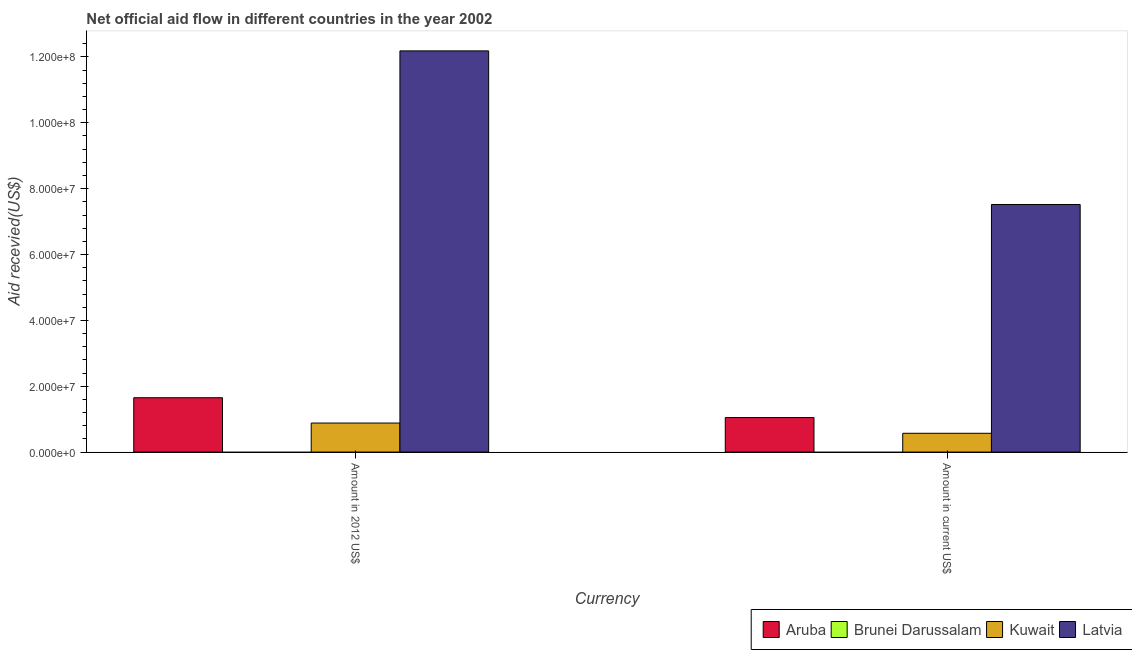How many different coloured bars are there?
Keep it short and to the point. 3. How many groups of bars are there?
Your response must be concise. 2. Are the number of bars per tick equal to the number of legend labels?
Your response must be concise. No. Are the number of bars on each tick of the X-axis equal?
Your answer should be compact. Yes. What is the label of the 2nd group of bars from the left?
Your answer should be very brief. Amount in current US$. What is the amount of aid received(expressed in us$) in Aruba?
Your answer should be compact. 1.05e+07. Across all countries, what is the maximum amount of aid received(expressed in 2012 us$)?
Provide a succinct answer. 1.22e+08. Across all countries, what is the minimum amount of aid received(expressed in us$)?
Your response must be concise. 0. In which country was the amount of aid received(expressed in 2012 us$) maximum?
Provide a succinct answer. Latvia. What is the total amount of aid received(expressed in 2012 us$) in the graph?
Make the answer very short. 1.47e+08. What is the difference between the amount of aid received(expressed in us$) in Latvia and that in Kuwait?
Ensure brevity in your answer.  6.95e+07. What is the difference between the amount of aid received(expressed in 2012 us$) in Kuwait and the amount of aid received(expressed in us$) in Aruba?
Offer a terse response. -1.67e+06. What is the average amount of aid received(expressed in 2012 us$) per country?
Provide a succinct answer. 3.68e+07. What is the difference between the amount of aid received(expressed in 2012 us$) and amount of aid received(expressed in us$) in Latvia?
Make the answer very short. 4.66e+07. What is the ratio of the amount of aid received(expressed in us$) in Latvia to that in Aruba?
Give a very brief answer. 7.17. Is the amount of aid received(expressed in us$) in Aruba less than that in Latvia?
Offer a very short reply. Yes. How many bars are there?
Your response must be concise. 6. Are all the bars in the graph horizontal?
Offer a terse response. No. How many countries are there in the graph?
Keep it short and to the point. 4. Are the values on the major ticks of Y-axis written in scientific E-notation?
Keep it short and to the point. Yes. Does the graph contain grids?
Your answer should be compact. No. Where does the legend appear in the graph?
Provide a succinct answer. Bottom right. How many legend labels are there?
Provide a succinct answer. 4. What is the title of the graph?
Provide a short and direct response. Net official aid flow in different countries in the year 2002. What is the label or title of the X-axis?
Provide a short and direct response. Currency. What is the label or title of the Y-axis?
Your response must be concise. Aid recevied(US$). What is the Aid recevied(US$) in Aruba in Amount in 2012 US$?
Provide a short and direct response. 1.65e+07. What is the Aid recevied(US$) in Kuwait in Amount in 2012 US$?
Your answer should be very brief. 8.82e+06. What is the Aid recevied(US$) of Latvia in Amount in 2012 US$?
Make the answer very short. 1.22e+08. What is the Aid recevied(US$) of Aruba in Amount in current US$?
Ensure brevity in your answer.  1.05e+07. What is the Aid recevied(US$) of Kuwait in Amount in current US$?
Offer a very short reply. 5.71e+06. What is the Aid recevied(US$) in Latvia in Amount in current US$?
Give a very brief answer. 7.52e+07. Across all Currency, what is the maximum Aid recevied(US$) of Aruba?
Ensure brevity in your answer.  1.65e+07. Across all Currency, what is the maximum Aid recevied(US$) of Kuwait?
Offer a very short reply. 8.82e+06. Across all Currency, what is the maximum Aid recevied(US$) in Latvia?
Provide a succinct answer. 1.22e+08. Across all Currency, what is the minimum Aid recevied(US$) in Aruba?
Make the answer very short. 1.05e+07. Across all Currency, what is the minimum Aid recevied(US$) in Kuwait?
Your answer should be very brief. 5.71e+06. Across all Currency, what is the minimum Aid recevied(US$) of Latvia?
Keep it short and to the point. 7.52e+07. What is the total Aid recevied(US$) of Aruba in the graph?
Your response must be concise. 2.70e+07. What is the total Aid recevied(US$) in Brunei Darussalam in the graph?
Give a very brief answer. 0. What is the total Aid recevied(US$) of Kuwait in the graph?
Your answer should be compact. 1.45e+07. What is the total Aid recevied(US$) of Latvia in the graph?
Provide a succinct answer. 1.97e+08. What is the difference between the Aid recevied(US$) in Aruba in Amount in 2012 US$ and that in Amount in current US$?
Offer a very short reply. 6.02e+06. What is the difference between the Aid recevied(US$) of Kuwait in Amount in 2012 US$ and that in Amount in current US$?
Ensure brevity in your answer.  3.11e+06. What is the difference between the Aid recevied(US$) in Latvia in Amount in 2012 US$ and that in Amount in current US$?
Your answer should be very brief. 4.66e+07. What is the difference between the Aid recevied(US$) of Aruba in Amount in 2012 US$ and the Aid recevied(US$) of Kuwait in Amount in current US$?
Your answer should be compact. 1.08e+07. What is the difference between the Aid recevied(US$) of Aruba in Amount in 2012 US$ and the Aid recevied(US$) of Latvia in Amount in current US$?
Your answer should be compact. -5.87e+07. What is the difference between the Aid recevied(US$) in Kuwait in Amount in 2012 US$ and the Aid recevied(US$) in Latvia in Amount in current US$?
Your answer should be compact. -6.64e+07. What is the average Aid recevied(US$) in Aruba per Currency?
Provide a short and direct response. 1.35e+07. What is the average Aid recevied(US$) of Kuwait per Currency?
Provide a succinct answer. 7.26e+06. What is the average Aid recevied(US$) in Latvia per Currency?
Offer a terse response. 9.85e+07. What is the difference between the Aid recevied(US$) of Aruba and Aid recevied(US$) of Kuwait in Amount in 2012 US$?
Ensure brevity in your answer.  7.69e+06. What is the difference between the Aid recevied(US$) of Aruba and Aid recevied(US$) of Latvia in Amount in 2012 US$?
Your answer should be compact. -1.05e+08. What is the difference between the Aid recevied(US$) in Kuwait and Aid recevied(US$) in Latvia in Amount in 2012 US$?
Your answer should be compact. -1.13e+08. What is the difference between the Aid recevied(US$) in Aruba and Aid recevied(US$) in Kuwait in Amount in current US$?
Offer a very short reply. 4.78e+06. What is the difference between the Aid recevied(US$) of Aruba and Aid recevied(US$) of Latvia in Amount in current US$?
Provide a succinct answer. -6.47e+07. What is the difference between the Aid recevied(US$) of Kuwait and Aid recevied(US$) of Latvia in Amount in current US$?
Offer a terse response. -6.95e+07. What is the ratio of the Aid recevied(US$) in Aruba in Amount in 2012 US$ to that in Amount in current US$?
Offer a terse response. 1.57. What is the ratio of the Aid recevied(US$) in Kuwait in Amount in 2012 US$ to that in Amount in current US$?
Your answer should be very brief. 1.54. What is the ratio of the Aid recevied(US$) in Latvia in Amount in 2012 US$ to that in Amount in current US$?
Your response must be concise. 1.62. What is the difference between the highest and the second highest Aid recevied(US$) in Aruba?
Offer a terse response. 6.02e+06. What is the difference between the highest and the second highest Aid recevied(US$) of Kuwait?
Your answer should be very brief. 3.11e+06. What is the difference between the highest and the second highest Aid recevied(US$) in Latvia?
Give a very brief answer. 4.66e+07. What is the difference between the highest and the lowest Aid recevied(US$) in Aruba?
Make the answer very short. 6.02e+06. What is the difference between the highest and the lowest Aid recevied(US$) in Kuwait?
Provide a short and direct response. 3.11e+06. What is the difference between the highest and the lowest Aid recevied(US$) of Latvia?
Your response must be concise. 4.66e+07. 